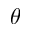Convert formula to latex. <formula><loc_0><loc_0><loc_500><loc_500>\theta</formula> 